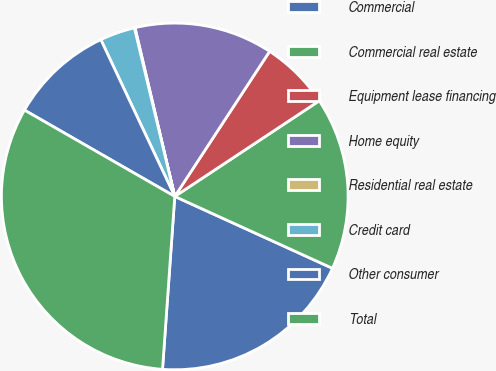Convert chart to OTSL. <chart><loc_0><loc_0><loc_500><loc_500><pie_chart><fcel>Commercial<fcel>Commercial real estate<fcel>Equipment lease financing<fcel>Home equity<fcel>Residential real estate<fcel>Credit card<fcel>Other consumer<fcel>Total<nl><fcel>19.32%<fcel>16.11%<fcel>6.48%<fcel>12.9%<fcel>0.06%<fcel>3.27%<fcel>9.69%<fcel>32.17%<nl></chart> 